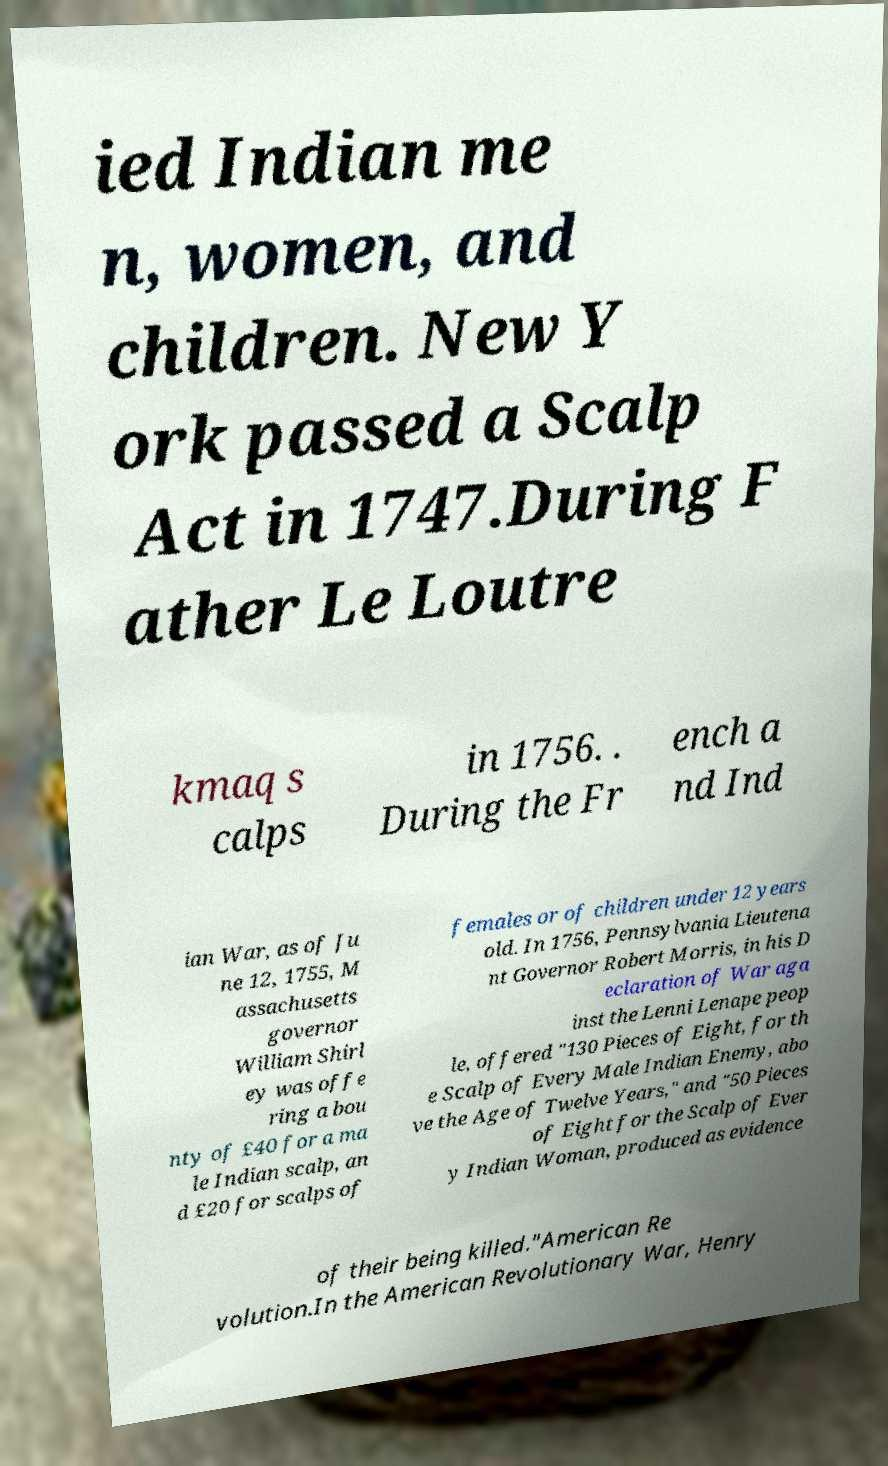Could you extract and type out the text from this image? ied Indian me n, women, and children. New Y ork passed a Scalp Act in 1747.During F ather Le Loutre kmaq s calps in 1756. . During the Fr ench a nd Ind ian War, as of Ju ne 12, 1755, M assachusetts governor William Shirl ey was offe ring a bou nty of £40 for a ma le Indian scalp, an d £20 for scalps of females or of children under 12 years old. In 1756, Pennsylvania Lieutena nt Governor Robert Morris, in his D eclaration of War aga inst the Lenni Lenape peop le, offered "130 Pieces of Eight, for th e Scalp of Every Male Indian Enemy, abo ve the Age of Twelve Years," and "50 Pieces of Eight for the Scalp of Ever y Indian Woman, produced as evidence of their being killed."American Re volution.In the American Revolutionary War, Henry 